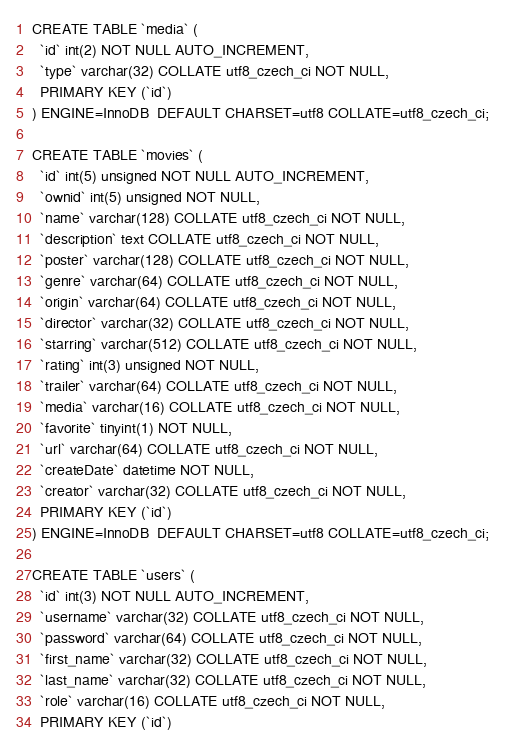Convert code to text. <code><loc_0><loc_0><loc_500><loc_500><_SQL_>CREATE TABLE `media` (
  `id` int(2) NOT NULL AUTO_INCREMENT,
  `type` varchar(32) COLLATE utf8_czech_ci NOT NULL,
  PRIMARY KEY (`id`)
) ENGINE=InnoDB  DEFAULT CHARSET=utf8 COLLATE=utf8_czech_ci;

CREATE TABLE `movies` (
  `id` int(5) unsigned NOT NULL AUTO_INCREMENT,
  `ownid` int(5) unsigned NOT NULL,
  `name` varchar(128) COLLATE utf8_czech_ci NOT NULL,
  `description` text COLLATE utf8_czech_ci NOT NULL,
  `poster` varchar(128) COLLATE utf8_czech_ci NOT NULL,
  `genre` varchar(64) COLLATE utf8_czech_ci NOT NULL,
  `origin` varchar(64) COLLATE utf8_czech_ci NOT NULL,
  `director` varchar(32) COLLATE utf8_czech_ci NOT NULL,
  `starring` varchar(512) COLLATE utf8_czech_ci NOT NULL,
  `rating` int(3) unsigned NOT NULL,
  `trailer` varchar(64) COLLATE utf8_czech_ci NOT NULL,
  `media` varchar(16) COLLATE utf8_czech_ci NOT NULL,
  `favorite` tinyint(1) NOT NULL,
  `url` varchar(64) COLLATE utf8_czech_ci NOT NULL,
  `createDate` datetime NOT NULL,
  `creator` varchar(32) COLLATE utf8_czech_ci NOT NULL,
  PRIMARY KEY (`id`)
) ENGINE=InnoDB  DEFAULT CHARSET=utf8 COLLATE=utf8_czech_ci;

CREATE TABLE `users` (
  `id` int(3) NOT NULL AUTO_INCREMENT,
  `username` varchar(32) COLLATE utf8_czech_ci NOT NULL,
  `password` varchar(64) COLLATE utf8_czech_ci NOT NULL,
  `first_name` varchar(32) COLLATE utf8_czech_ci NOT NULL,
  `last_name` varchar(32) COLLATE utf8_czech_ci NOT NULL,
  `role` varchar(16) COLLATE utf8_czech_ci NOT NULL,
  PRIMARY KEY (`id`)</code> 